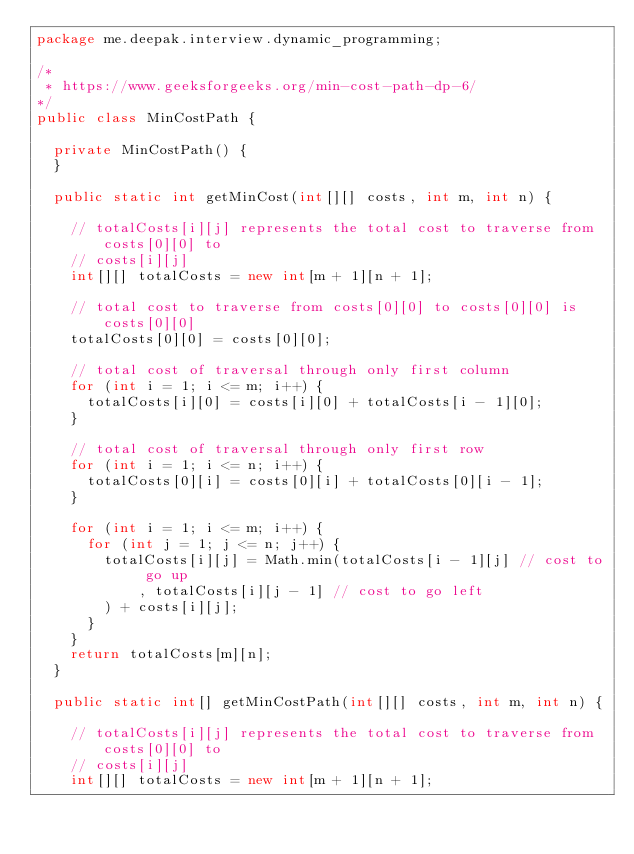<code> <loc_0><loc_0><loc_500><loc_500><_Java_>package me.deepak.interview.dynamic_programming;

/*
 * https://www.geeksforgeeks.org/min-cost-path-dp-6/
*/
public class MinCostPath {

	private MinCostPath() {
	}

	public static int getMinCost(int[][] costs, int m, int n) {

		// totalCosts[i][j] represents the total cost to traverse from costs[0][0] to
		// costs[i][j]
		int[][] totalCosts = new int[m + 1][n + 1];

		// total cost to traverse from costs[0][0] to costs[0][0] is costs[0][0]
		totalCosts[0][0] = costs[0][0];

		// total cost of traversal through only first column
		for (int i = 1; i <= m; i++) {
			totalCosts[i][0] = costs[i][0] + totalCosts[i - 1][0];
		}

		// total cost of traversal through only first row
		for (int i = 1; i <= n; i++) {
			totalCosts[0][i] = costs[0][i] + totalCosts[0][i - 1];
		}

		for (int i = 1; i <= m; i++) {
			for (int j = 1; j <= n; j++) {
				totalCosts[i][j] = Math.min(totalCosts[i - 1][j] // cost to go up
						, totalCosts[i][j - 1] // cost to go left
				) + costs[i][j];
			}
		}
		return totalCosts[m][n];
	}

	public static int[] getMinCostPath(int[][] costs, int m, int n) {

		// totalCosts[i][j] represents the total cost to traverse from costs[0][0] to
		// costs[i][j]
		int[][] totalCosts = new int[m + 1][n + 1];
</code> 